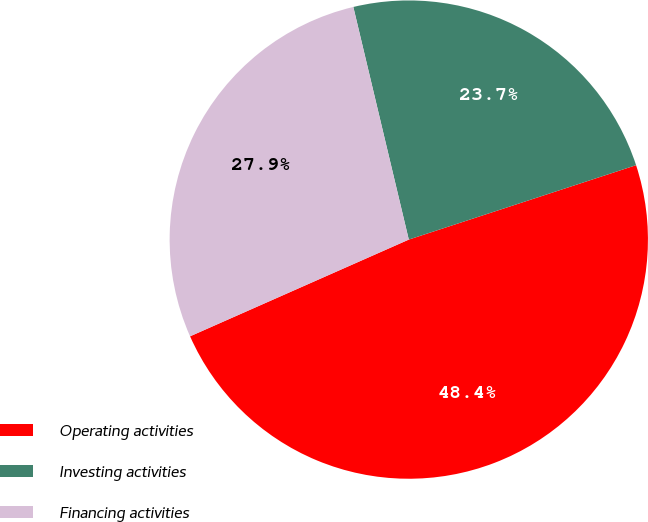Convert chart to OTSL. <chart><loc_0><loc_0><loc_500><loc_500><pie_chart><fcel>Operating activities<fcel>Investing activities<fcel>Financing activities<nl><fcel>48.41%<fcel>23.69%<fcel>27.9%<nl></chart> 